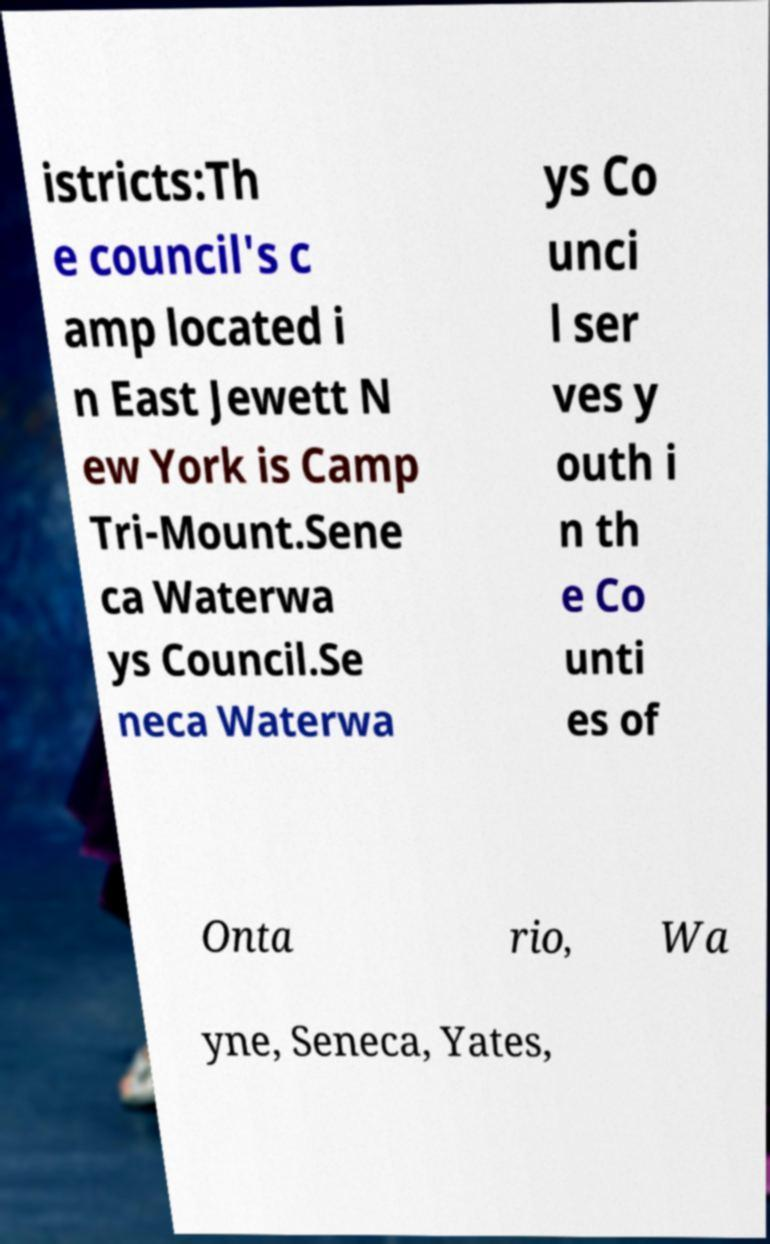Can you accurately transcribe the text from the provided image for me? istricts:Th e council's c amp located i n East Jewett N ew York is Camp Tri-Mount.Sene ca Waterwa ys Council.Se neca Waterwa ys Co unci l ser ves y outh i n th e Co unti es of Onta rio, Wa yne, Seneca, Yates, 